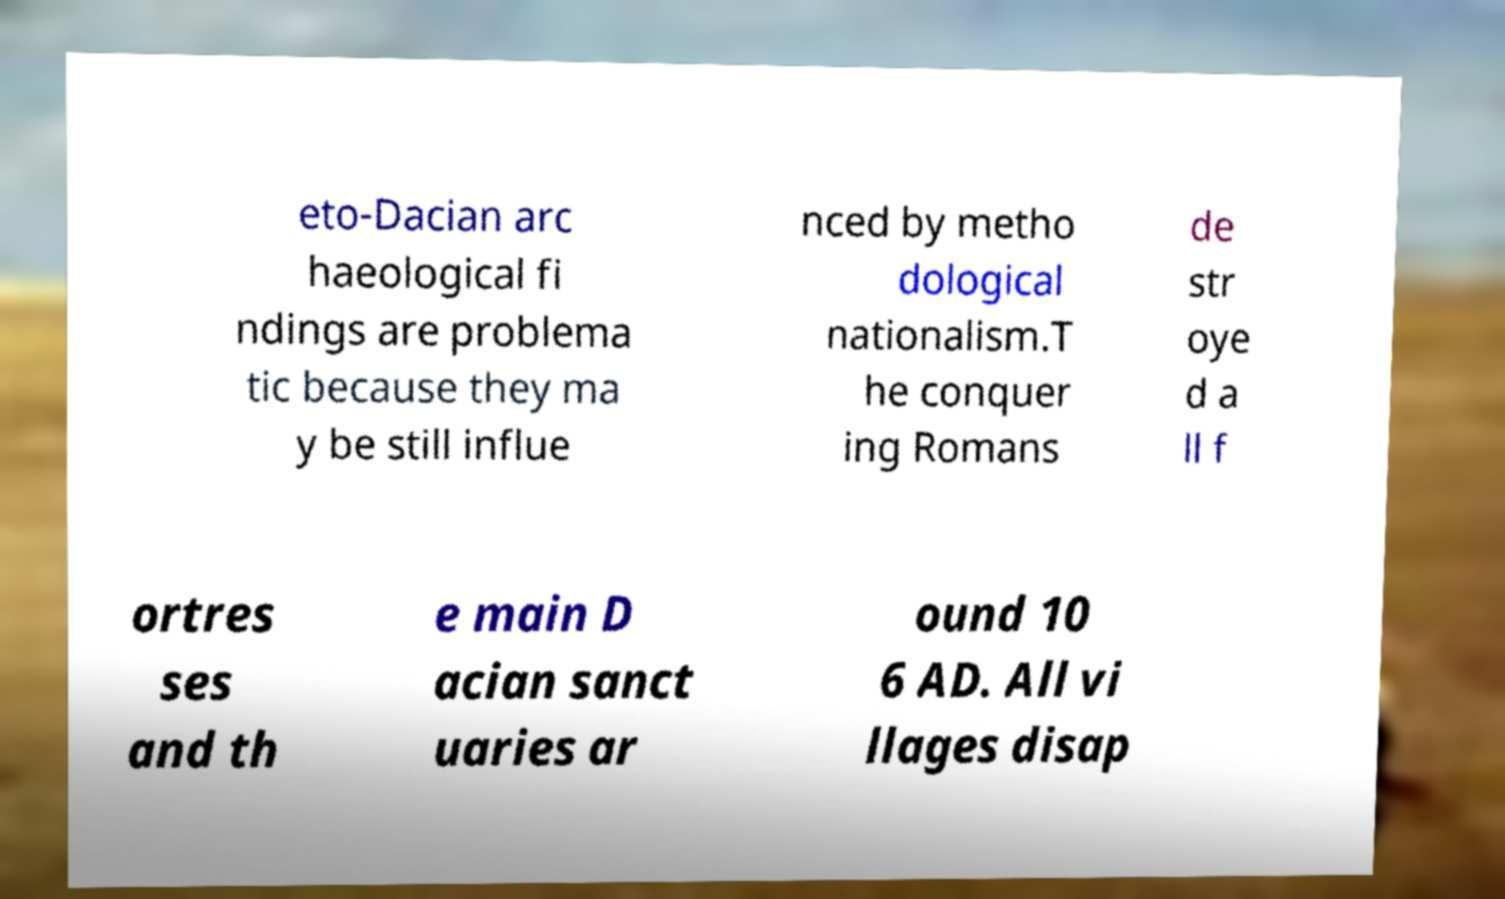Could you assist in decoding the text presented in this image and type it out clearly? eto-Dacian arc haeological fi ndings are problema tic because they ma y be still influe nced by metho dological nationalism.T he conquer ing Romans de str oye d a ll f ortres ses and th e main D acian sanct uaries ar ound 10 6 AD. All vi llages disap 